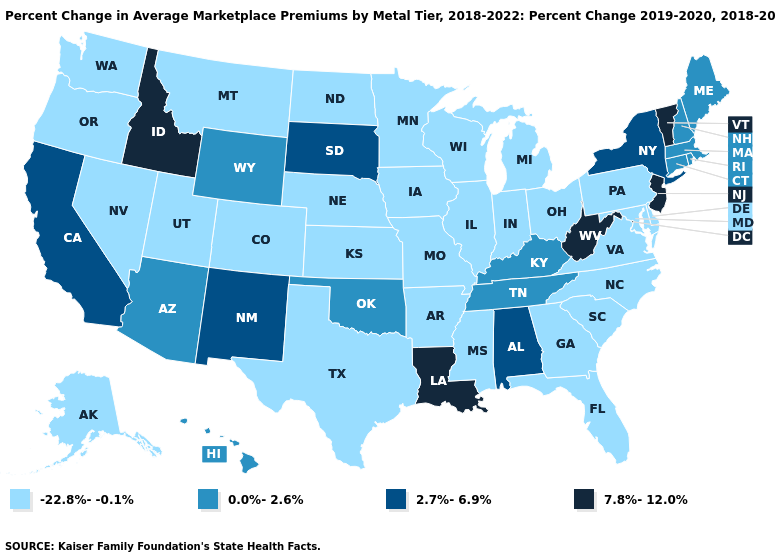Does Delaware have the lowest value in the USA?
Give a very brief answer. Yes. What is the lowest value in the West?
Quick response, please. -22.8%--0.1%. Which states have the highest value in the USA?
Be succinct. Idaho, Louisiana, New Jersey, Vermont, West Virginia. What is the value of Virginia?
Short answer required. -22.8%--0.1%. What is the value of Nevada?
Write a very short answer. -22.8%--0.1%. Does Maine have a higher value than Kentucky?
Quick response, please. No. What is the value of North Carolina?
Concise answer only. -22.8%--0.1%. Does the map have missing data?
Concise answer only. No. What is the value of Delaware?
Write a very short answer. -22.8%--0.1%. What is the value of Kansas?
Keep it brief. -22.8%--0.1%. Among the states that border Montana , does Wyoming have the lowest value?
Keep it brief. No. What is the highest value in the West ?
Write a very short answer. 7.8%-12.0%. Name the states that have a value in the range 7.8%-12.0%?
Give a very brief answer. Idaho, Louisiana, New Jersey, Vermont, West Virginia. Name the states that have a value in the range 7.8%-12.0%?
Answer briefly. Idaho, Louisiana, New Jersey, Vermont, West Virginia. How many symbols are there in the legend?
Quick response, please. 4. 